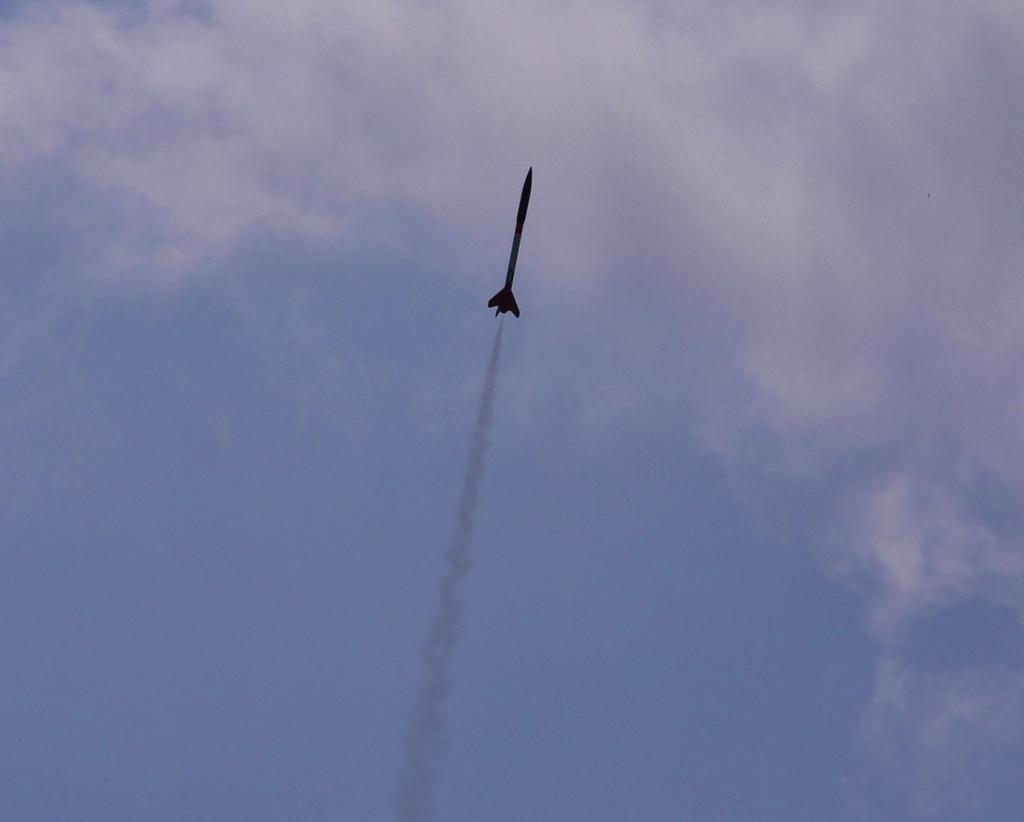Please provide a concise description of this image. In this image I see the missile over here and I see the smoke. In the background I see the clear sky. 